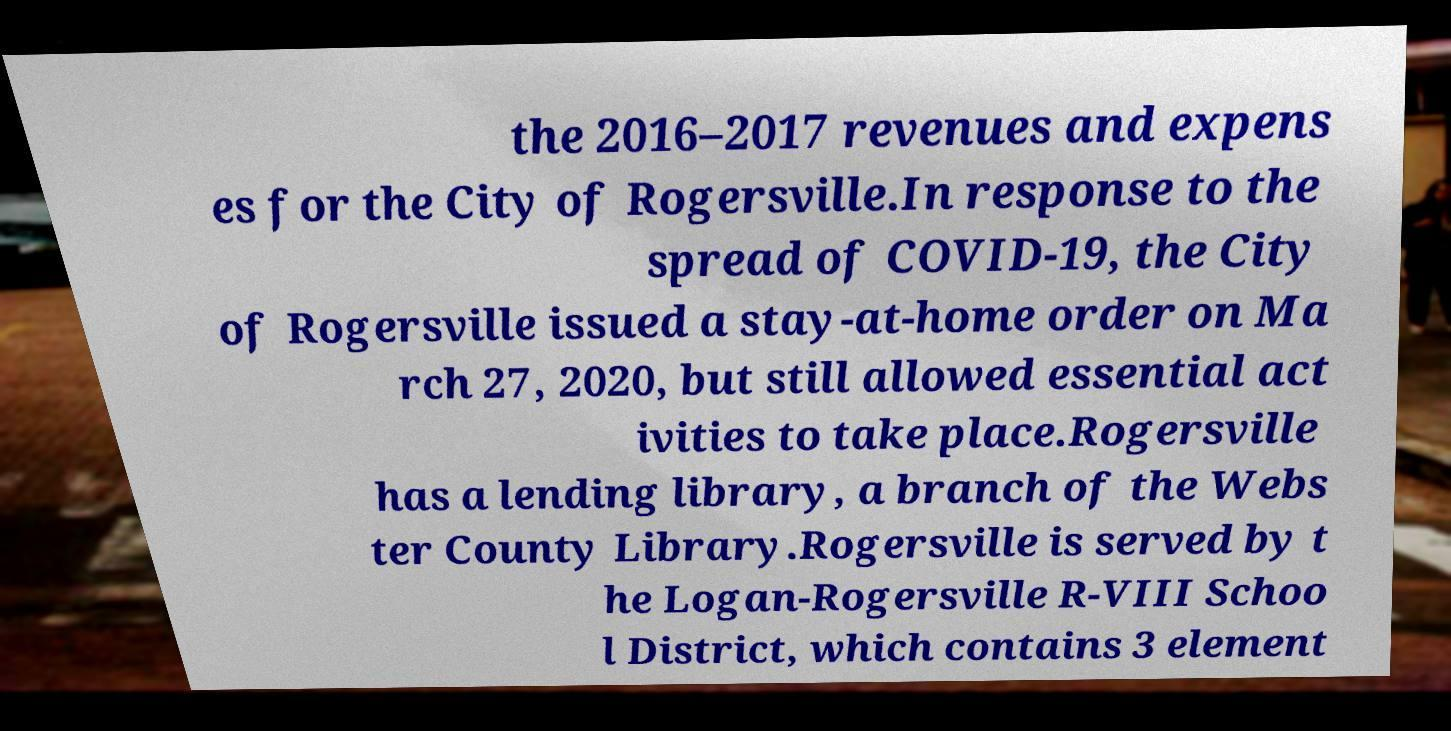Can you accurately transcribe the text from the provided image for me? the 2016–2017 revenues and expens es for the City of Rogersville.In response to the spread of COVID-19, the City of Rogersville issued a stay-at-home order on Ma rch 27, 2020, but still allowed essential act ivities to take place.Rogersville has a lending library, a branch of the Webs ter County Library.Rogersville is served by t he Logan-Rogersville R-VIII Schoo l District, which contains 3 element 